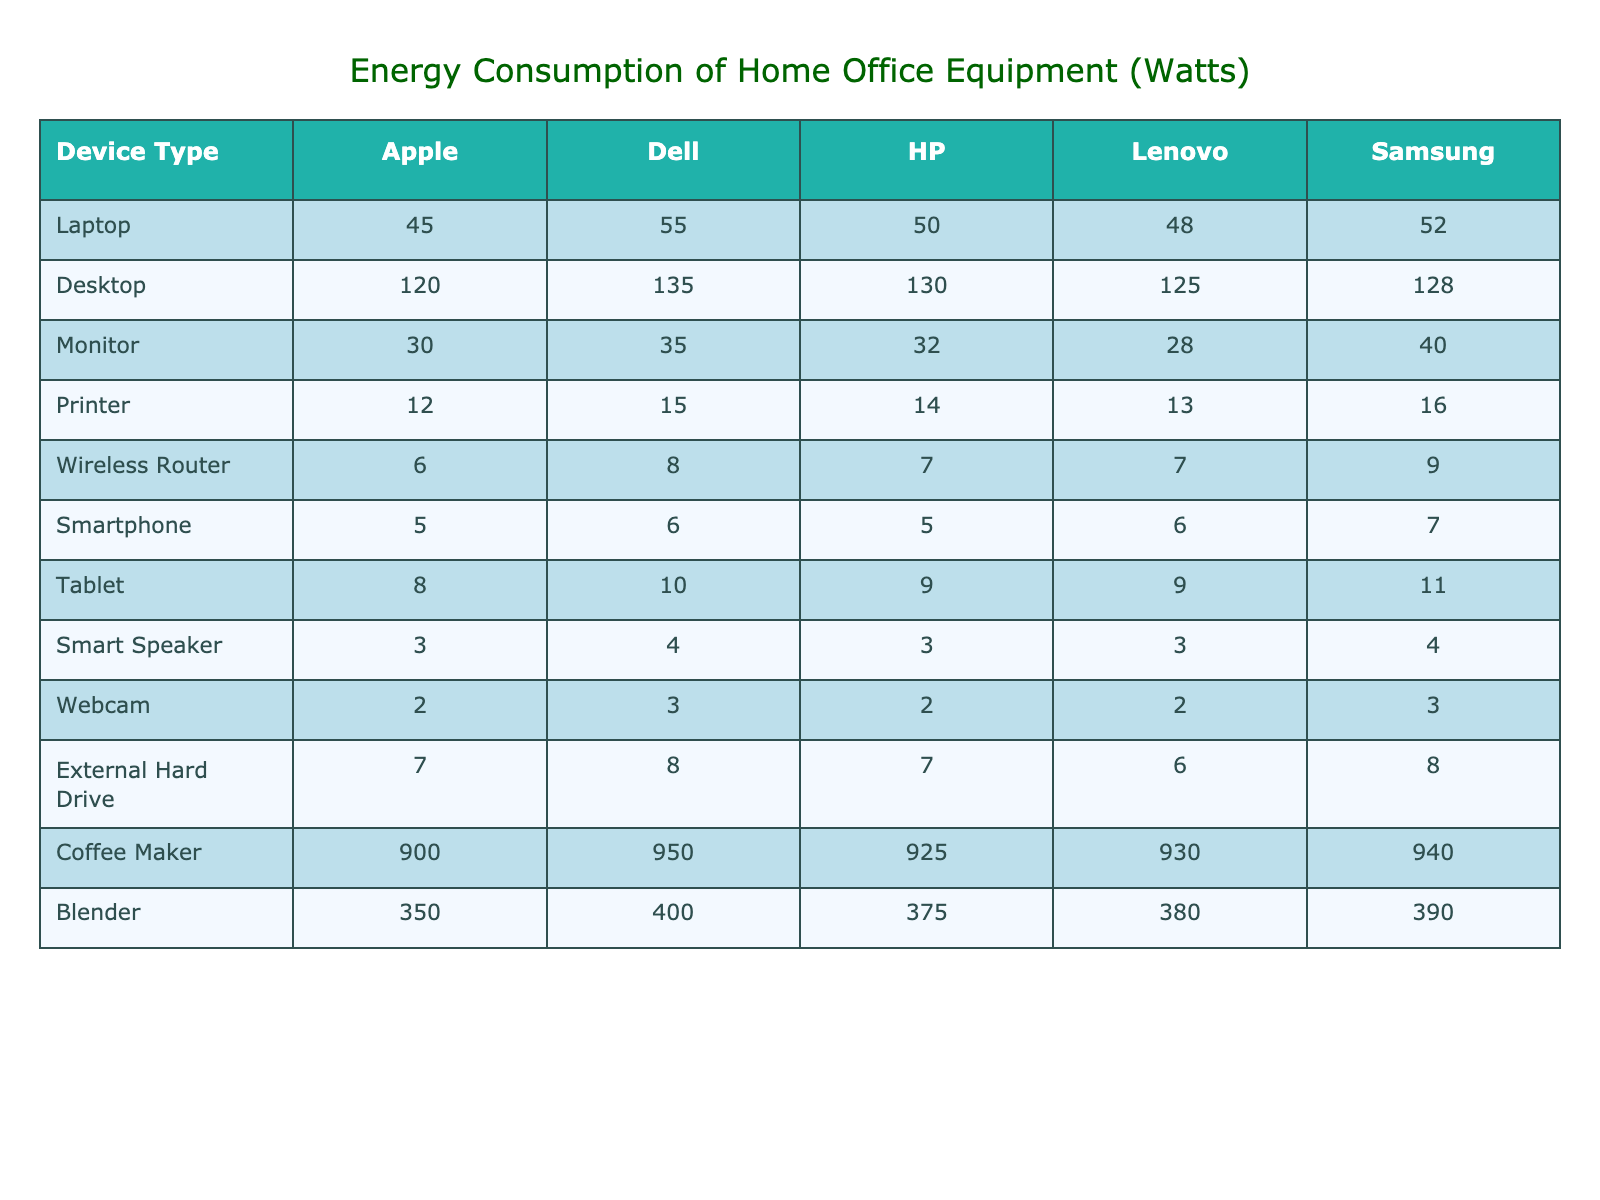What is the energy consumption of a Dell laptop? The energy consumption for a Dell laptop is listed in the table under the "Laptop" row and "Dell" column, which shows a value of 55 watts.
Answer: 55 watts Which brand has the highest energy consumption for desktops? By comparing the values in the "Desktop" row, Dell has the highest consumption at 135 watts.
Answer: Dell How much more energy does a Lenovo printer consume compared to an Apple printer? The Lenovo printer consumes 13 watts and the Apple printer consumes 12 watts. The difference is 13 - 12 = 1 watt.
Answer: 1 watt What is the total energy consumption of a Samsung laptop and tablet? The Samsung laptop consumes 52 watts and the tablet consumes 11 watts. Therefore, total consumption is 52 + 11 = 63 watts.
Answer: 63 watts Is the energy consumption of the HP monitor less than 35 watts? The energy consumption of the HP monitor is 32 watts, which is less than 35 watts.
Answer: Yes What is the average power consumption of a coffee maker across all brands? The values for the coffee makers are 900 (Apple), 950 (Dell), 925 (HP), 930 (Lenovo), and 940 (Samsung). The average is (900 + 950 + 925 + 930 + 940) / 5 = 929 watts.
Answer: 929 watts Which device consumes the most power, and what is the value? The highest value in the table is found in the "Coffee Maker" row for all brands, with the highest being Dell at 950 watts.
Answer: 950 watts If I replace my Apple desktop with a Samsung one, how much energy will I save? The Apple desktop consumes 120 watts, and the Samsung one consumes 128 watts. The difference is 120 - 128 = -8 watts, meaning you'll consume 8 watts more.
Answer: 8 watts more What is the total energy consumption of all Lenovo devices listed in the table? The Lenovo energy consumptions are 48 (laptop) + 125 (desktop) + 28 (monitor) + 13 (printer) + 7 (wireless router) + 6 (smartphone) + 9 (tablet) + 3 (smart speaker) + 2 (webcam) + 6 (external hard drive) + 930 (coffee maker) + 380 (blender). Adding these values gives a total of 1,655 watts.
Answer: 1,655 watts Is the energy consumption of smartphones across all brands higher than that of tablets? The total consumption for smartphones is (5 + 6 + 5 + 6 + 7) = 29 watts while tablets consume (8 + 10 + 9 + 9 + 11) = 47 watts. Therefore, smartphones consume less.
Answer: No 